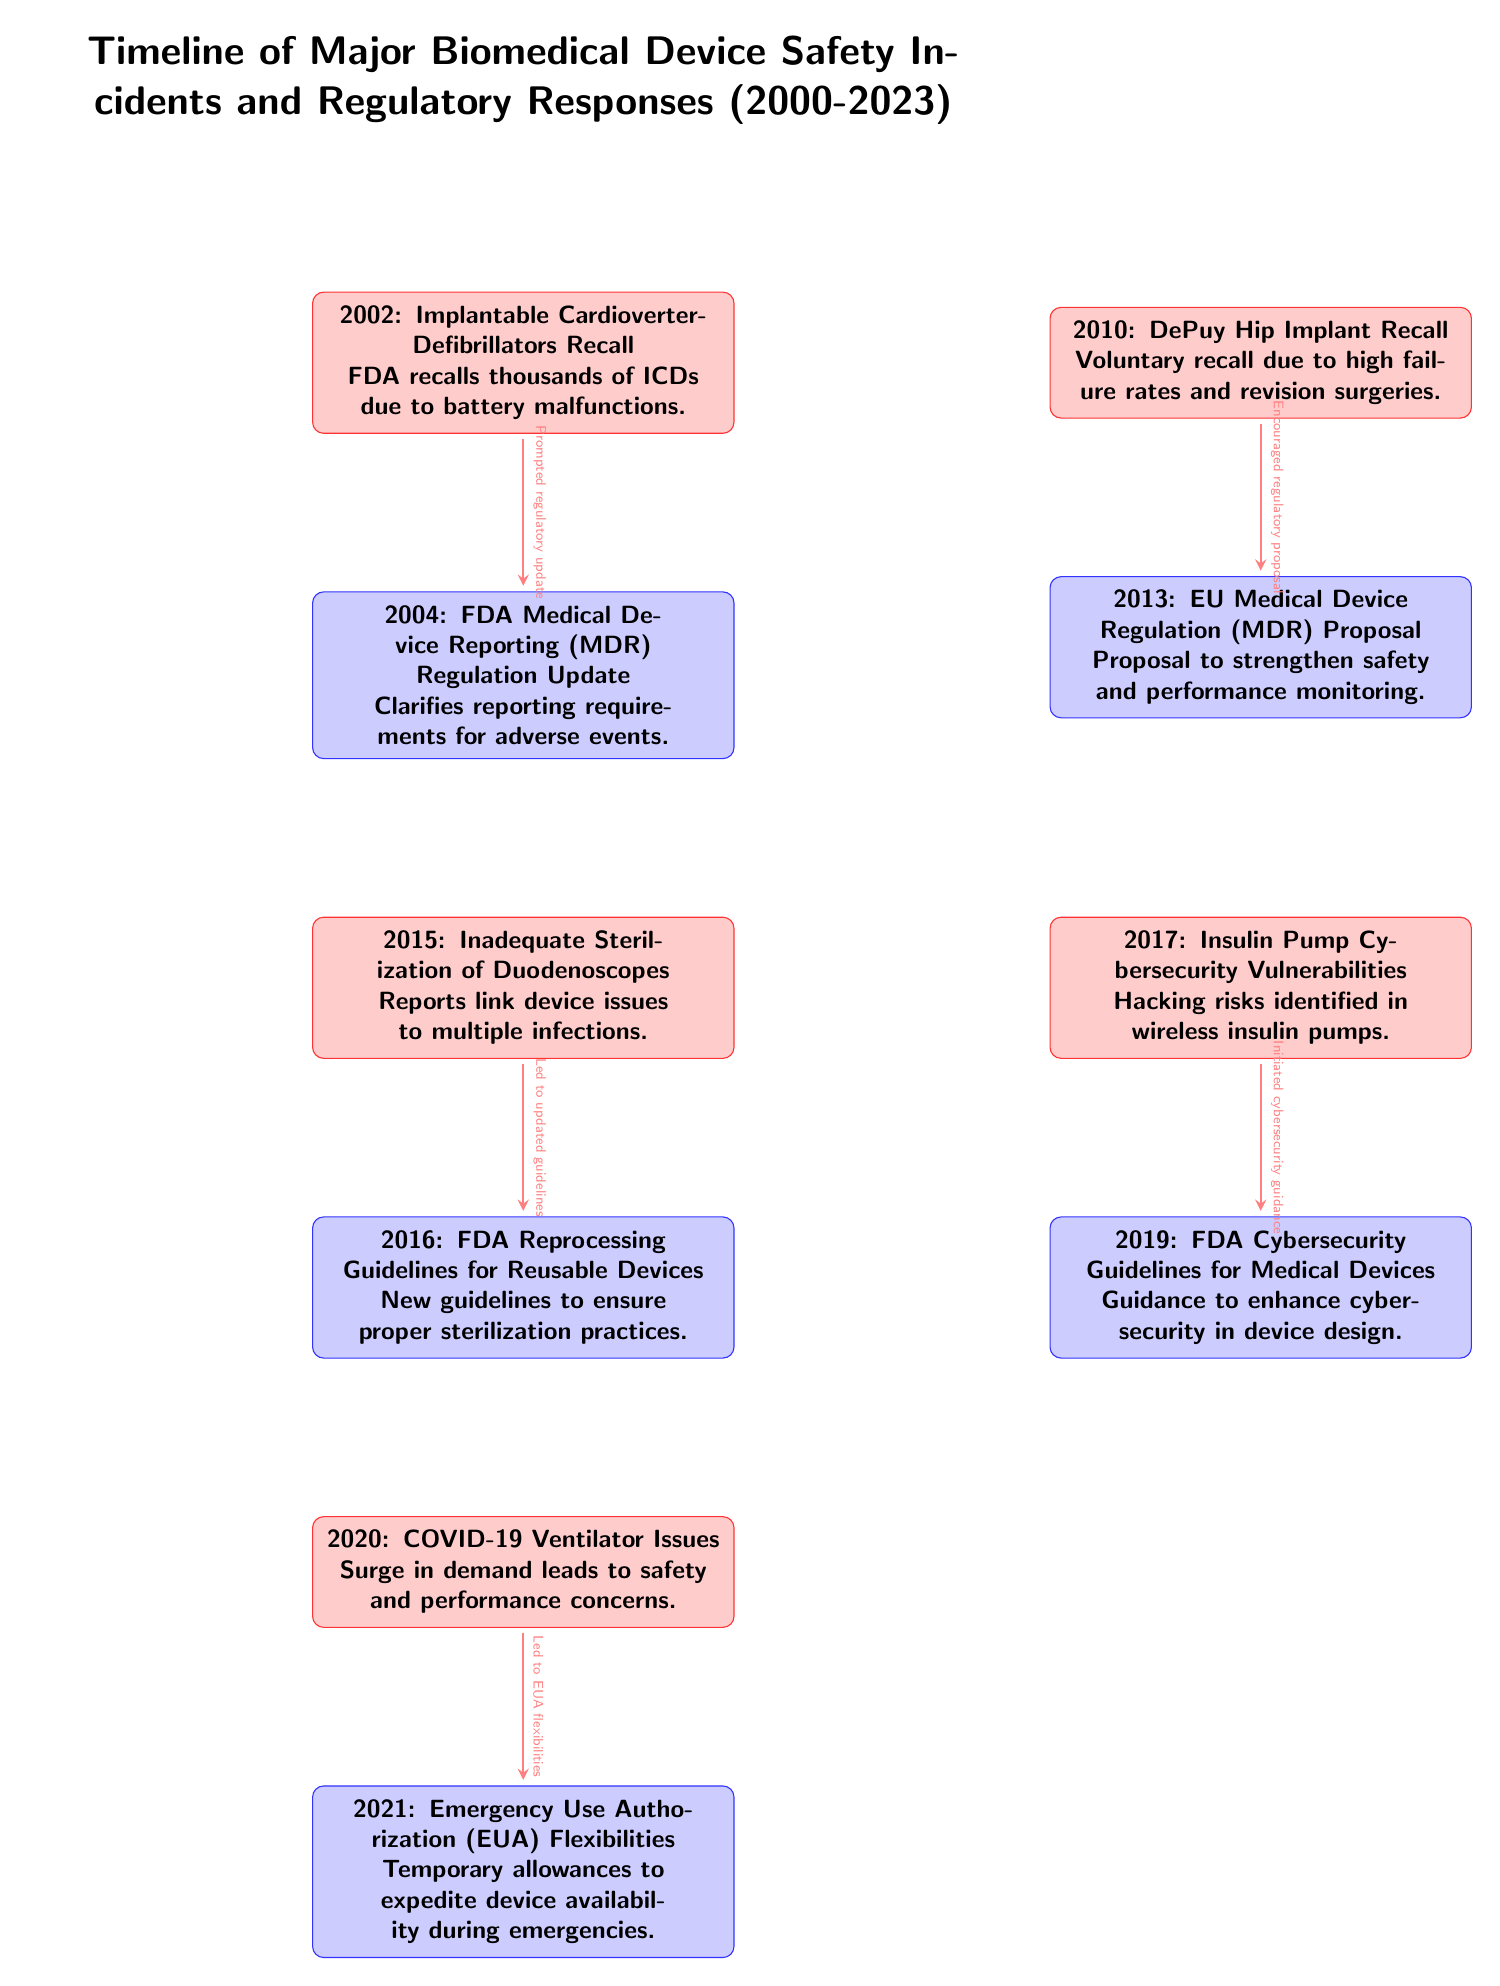What incident occurred in 2002? The diagram specifies that in 2002, there was an "Implantable Cardioverter-Defibrillators Recall" due to battery malfunctions.
Answer: Implantable Cardioverter-Defibrillators Recall What year did the FDA update the Medical Device Reporting Regulation? From the diagram, it is noted that the FDA updated the Medical Device Reporting Regulation in 2004 following the 2002 incident.
Answer: 2004 What was one of the issues reported in 2015? The diagram indicates that in 2015, there were reports linking "Inadequate Sterilization of Duodenoscopes" to multiple infections.
Answer: Inadequate Sterilization of Duodenoscopes How did the 2010 DePuy Hip Implant Recall influence regulations? According to the diagram, the "2010 DePuy Hip Implant Recall" encouraged a regulatory proposal in 2013 to strengthen safety and performance monitoring.
Answer: Encouraged regulatory proposal What guideline was introduced in response to the 2015 incident? The diagram states that in 2016, the FDA introduced "Reprocessing Guidelines for Reusable Devices" as a response to the 2015 incident regarding sterilization.
Answer: FDA Reprocessing Guidelines for Reusable Devices What incident involved cybersecurity vulnerabilities? The diagram shows that in 2017, there were "Insulin Pump Cybersecurity Vulnerabilities" identified.
Answer: Insulin Pump Cybersecurity Vulnerabilities Which incident led to Emergency Use Authorization flexibilities? Based on the diagram, the "COVID-19 Ventilator Issues" in 2020 led to the introduction of Emergency Use Authorization flexibilities in 2021.
Answer: COVID-19 Ventilator Issues How many incidents are listed in the diagram? By counting the nodes for incidents in the diagram, there are five major biomedical device safety incidents shown.
Answer: 5 What year was the EU Medical Device Regulation proposal made? The diagram indicates that the proposal for the EU Medical Device Regulation was made in 2013, following the 2010 incident.
Answer: 2013 What event spurred the FDA to improve cybersecurity guidelines? The diagram states that the identification of "Insulin Pump Cybersecurity Vulnerabilities" in 2017 initiated the FDA's guidance to enhance cybersecurity in device design in 2019.
Answer: Insulin Pump Cybersecurity Vulnerabilities 